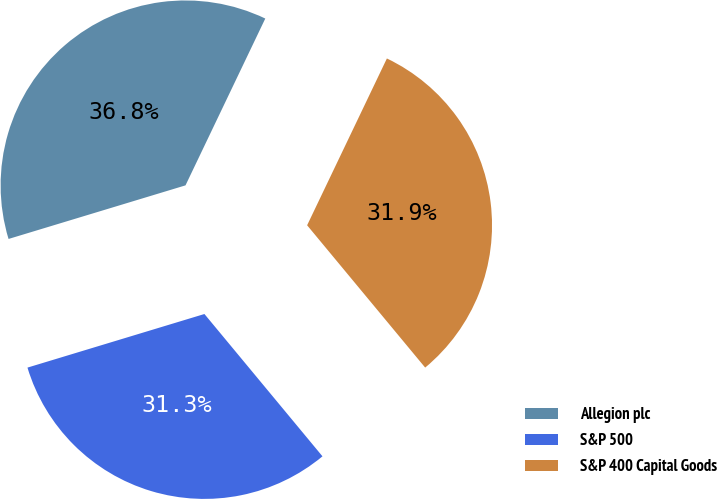Convert chart to OTSL. <chart><loc_0><loc_0><loc_500><loc_500><pie_chart><fcel>Allegion plc<fcel>S&P 500<fcel>S&P 400 Capital Goods<nl><fcel>36.78%<fcel>31.34%<fcel>31.88%<nl></chart> 